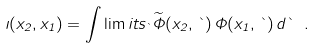<formula> <loc_0><loc_0><loc_500><loc_500>\zeta ( x _ { 2 } , x _ { 1 } ) = \int \lim i t s _ { \theta } \widetilde { \Phi } ( x _ { 2 } , \theta ) \, \Phi ( x _ { 1 } , \theta ) \, d \theta \ .</formula> 